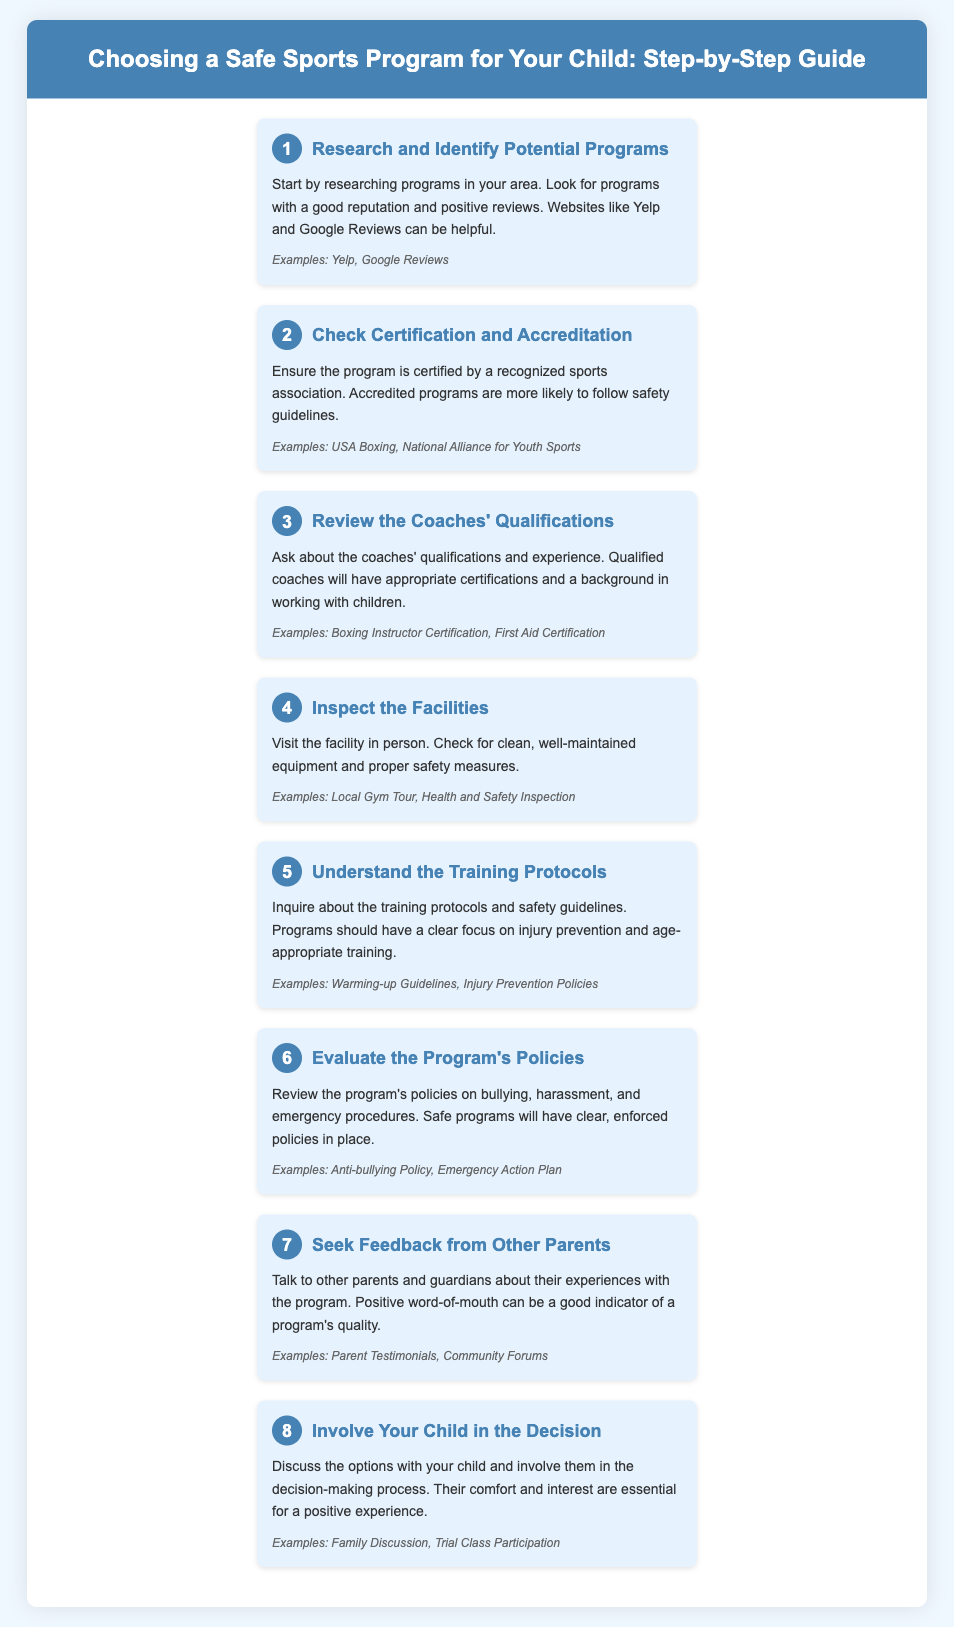What is the first step in choosing a safe sports program? The first step is to research programs in your area for those with a good reputation and positive reviews.
Answer: Research and Identify Potential Programs Which organizations provide certification for sports programs? The document states that accredited programs are certified by recognized sports associations.
Answer: USA Boxing, National Alliance for Youth Sports What should you check regarding the coaches? The document mentions that it is important to ask about the coaches' qualifications and experience.
Answer: Coaches' Qualifications What is essential to inspect in the facility? The document advises checking for clean, well-maintained equipment and proper safety measures.
Answer: Facility Inspection What do training protocols focus on? According to the document, training protocols should have a clear focus on injury prevention and age-appropriate training.
Answer: Injury Prevention How should you evaluate a program's policies? The document suggests reviewing policies on bullying and emergency procedures to ensure clarity and enforcement.
Answer: Evaluate Policies What is a good indicator of a program's quality? The document states that positive word-of-mouth from other parents can indicate a program’s quality.
Answer: Feedback from Other Parents How can you involve your child in the decision? The document recommends discussing options with your child and involving them in the decision-making process.
Answer: Family Discussion 